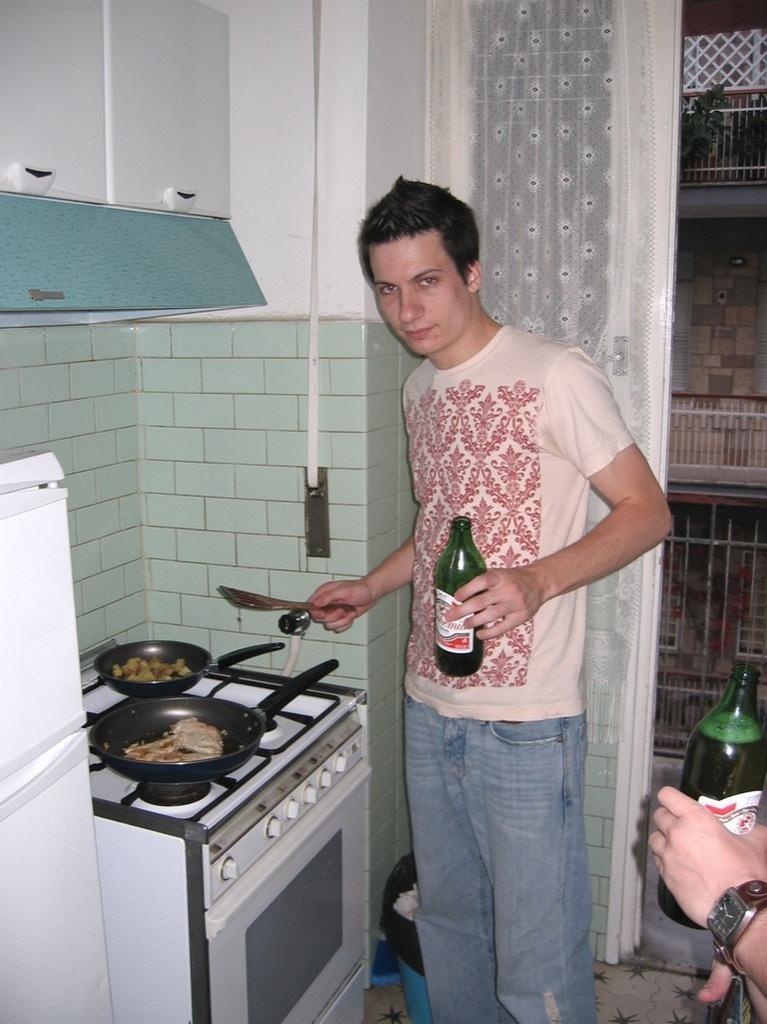How would you summarize this image in a sentence or two? In this image I can see a person standing and holding bottle and spoon. I can see food in pans. I can see stove,white color fridge,curtain,dustbin and wall. Back I can see building,fencing and small plants. 